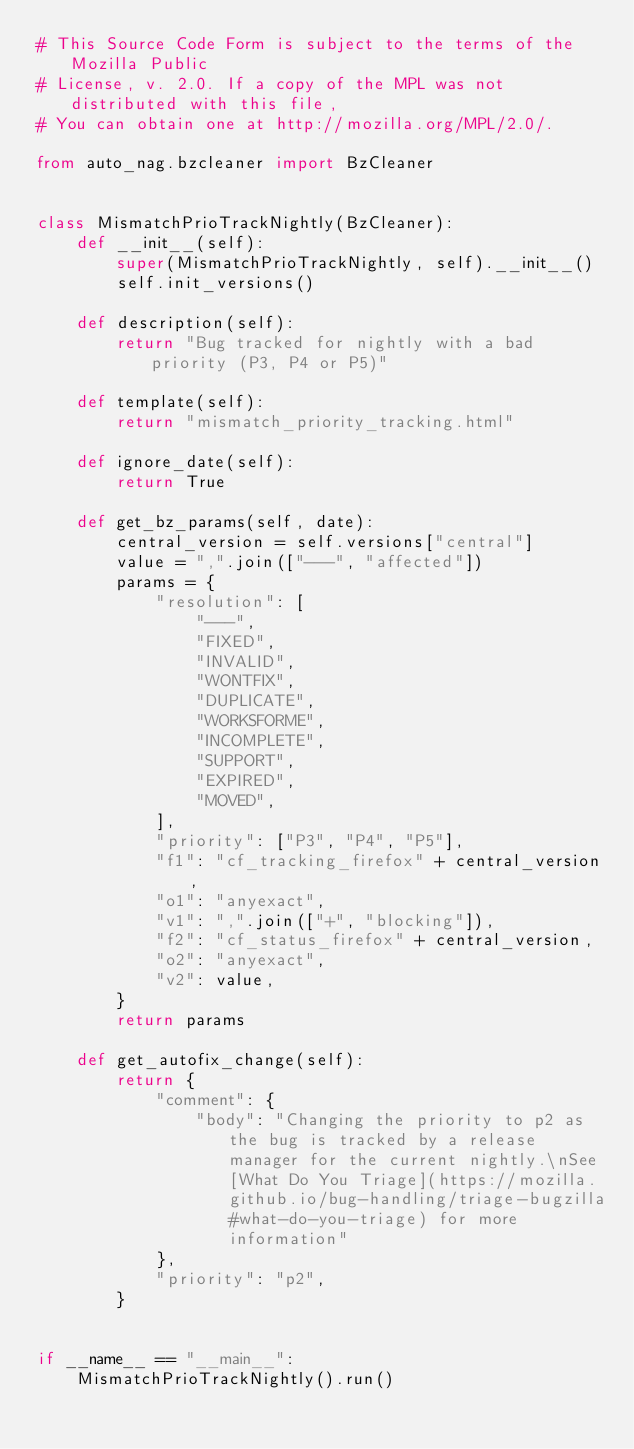<code> <loc_0><loc_0><loc_500><loc_500><_Python_># This Source Code Form is subject to the terms of the Mozilla Public
# License, v. 2.0. If a copy of the MPL was not distributed with this file,
# You can obtain one at http://mozilla.org/MPL/2.0/.

from auto_nag.bzcleaner import BzCleaner


class MismatchPrioTrackNightly(BzCleaner):
    def __init__(self):
        super(MismatchPrioTrackNightly, self).__init__()
        self.init_versions()

    def description(self):
        return "Bug tracked for nightly with a bad priority (P3, P4 or P5)"

    def template(self):
        return "mismatch_priority_tracking.html"

    def ignore_date(self):
        return True

    def get_bz_params(self, date):
        central_version = self.versions["central"]
        value = ",".join(["---", "affected"])
        params = {
            "resolution": [
                "---",
                "FIXED",
                "INVALID",
                "WONTFIX",
                "DUPLICATE",
                "WORKSFORME",
                "INCOMPLETE",
                "SUPPORT",
                "EXPIRED",
                "MOVED",
            ],
            "priority": ["P3", "P4", "P5"],
            "f1": "cf_tracking_firefox" + central_version,
            "o1": "anyexact",
            "v1": ",".join(["+", "blocking"]),
            "f2": "cf_status_firefox" + central_version,
            "o2": "anyexact",
            "v2": value,
        }
        return params

    def get_autofix_change(self):
        return {
            "comment": {
                "body": "Changing the priority to p2 as the bug is tracked by a release manager for the current nightly.\nSee [What Do You Triage](https://mozilla.github.io/bug-handling/triage-bugzilla#what-do-you-triage) for more information"
            },
            "priority": "p2",
        }


if __name__ == "__main__":
    MismatchPrioTrackNightly().run()
</code> 